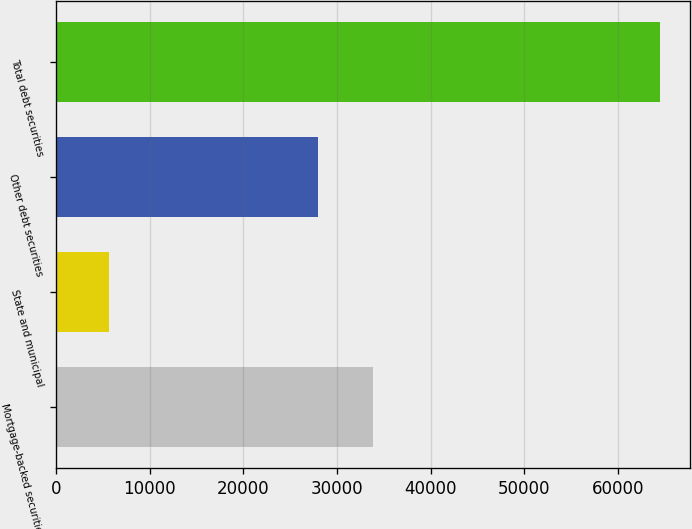<chart> <loc_0><loc_0><loc_500><loc_500><bar_chart><fcel>Mortgage-backed securities<fcel>State and municipal<fcel>Other debt securities<fcel>Total debt securities<nl><fcel>33895.8<fcel>5701<fcel>28020<fcel>64459<nl></chart> 